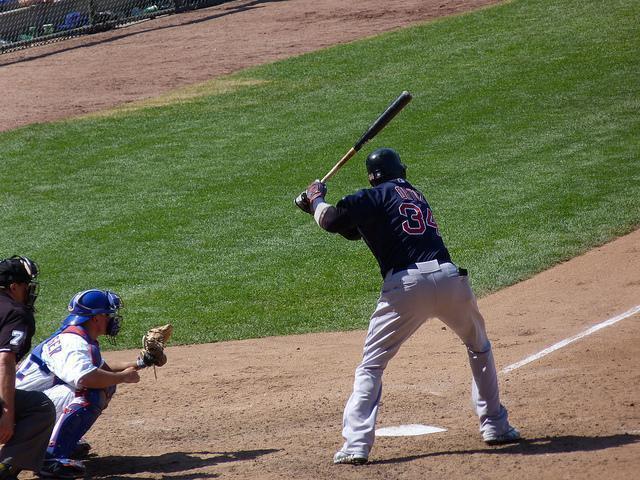What is the nickname of this player?
Make your selection and explain in format: 'Answer: answer
Rationale: rationale.'
Options: Closer, el hombre, big papi, slugger. Answer: big papi.
Rationale: The name is big papi. 